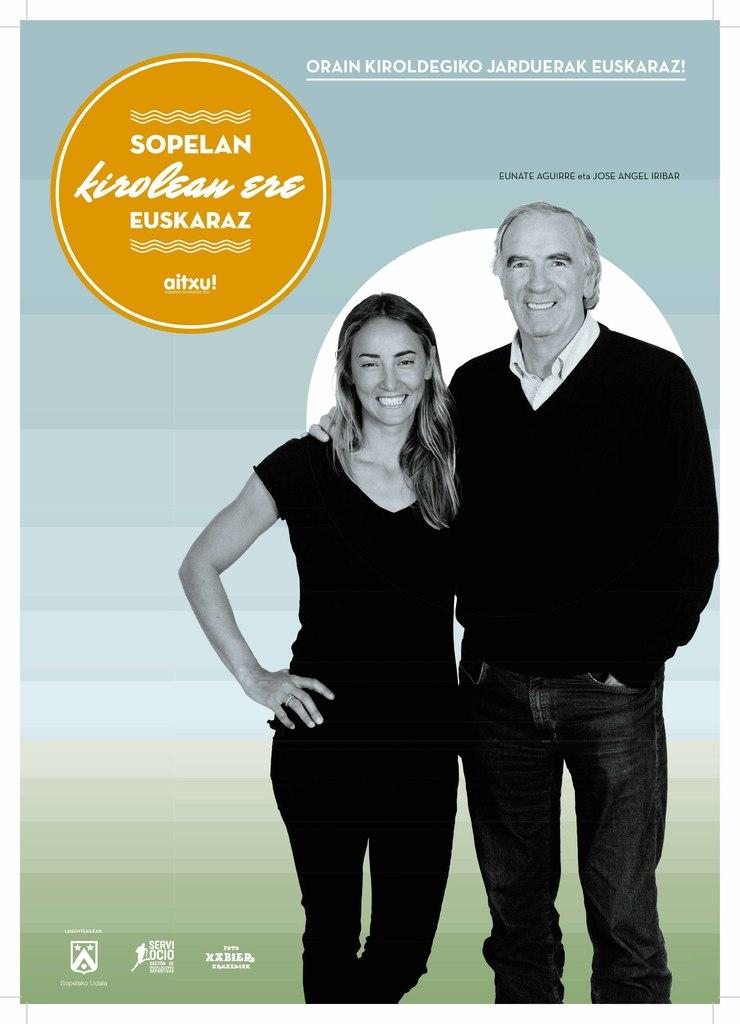What type of image is being described? The image is a poster. Who can be seen in the poster? There is a man and a woman in the poster. What are the man and woman doing in the poster? The man and woman are standing and smiling. What type of trail can be seen in the image? There is no trail present in the image; it is a poster featuring a man and a woman standing and smiling. What kind of boat is visible in the image? There is no boat present in the image; it is a poster featuring a man and a woman standing and smiling. 